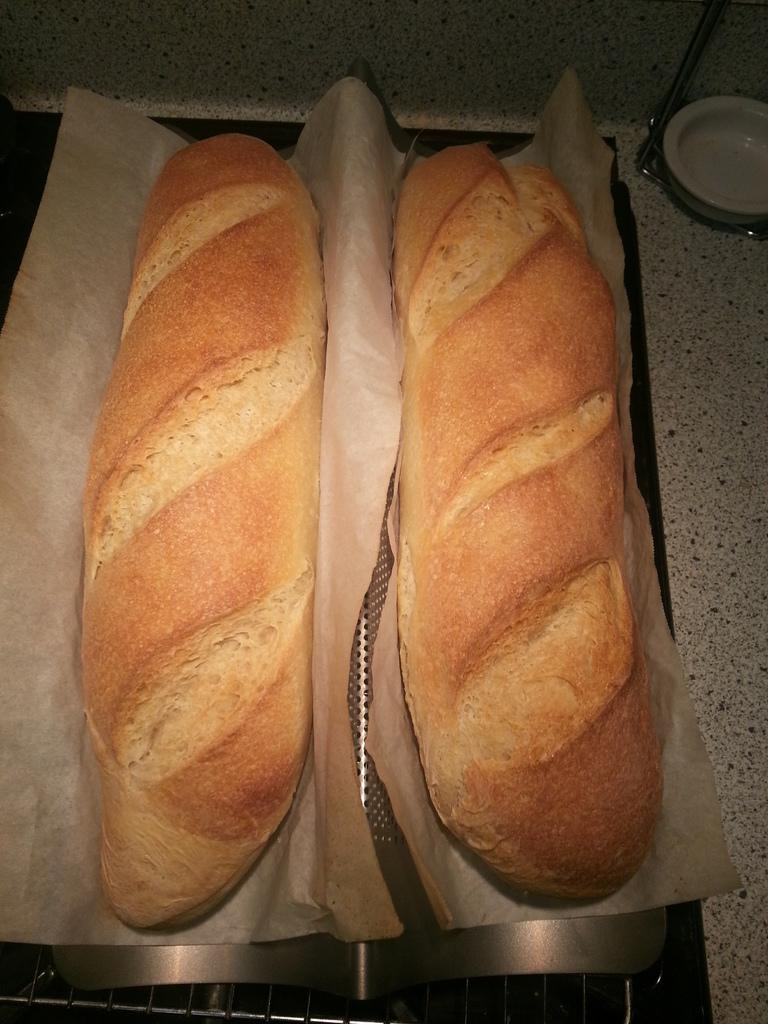What is the main subject in the image? There is a food item in the image. What is the food item placed on? The food item is on a tissue. How would you describe the color of the food item? The food item is in light brown color. What type of wood can be seen in the image? There is no wood present in the image. How much sugar is visible in the image? There is no sugar visible in the image. Is there any lettuce present in the image? There is no lettuce present in the image. 